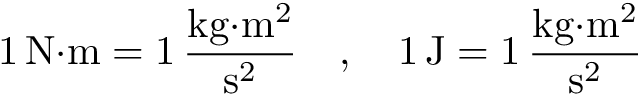Convert formula to latex. <formula><loc_0><loc_0><loc_500><loc_500>1 \, { N } { \cdot } m = 1 \, { \frac { { k g } { \cdot } { m } ^ { 2 } } { { s } ^ { 2 } } } \quad , \quad 1 \, J = 1 \, { \frac { k g { \cdot } m ^ { 2 } } { s ^ { 2 } } }</formula> 